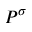<formula> <loc_0><loc_0><loc_500><loc_500>P ^ { \sigma }</formula> 